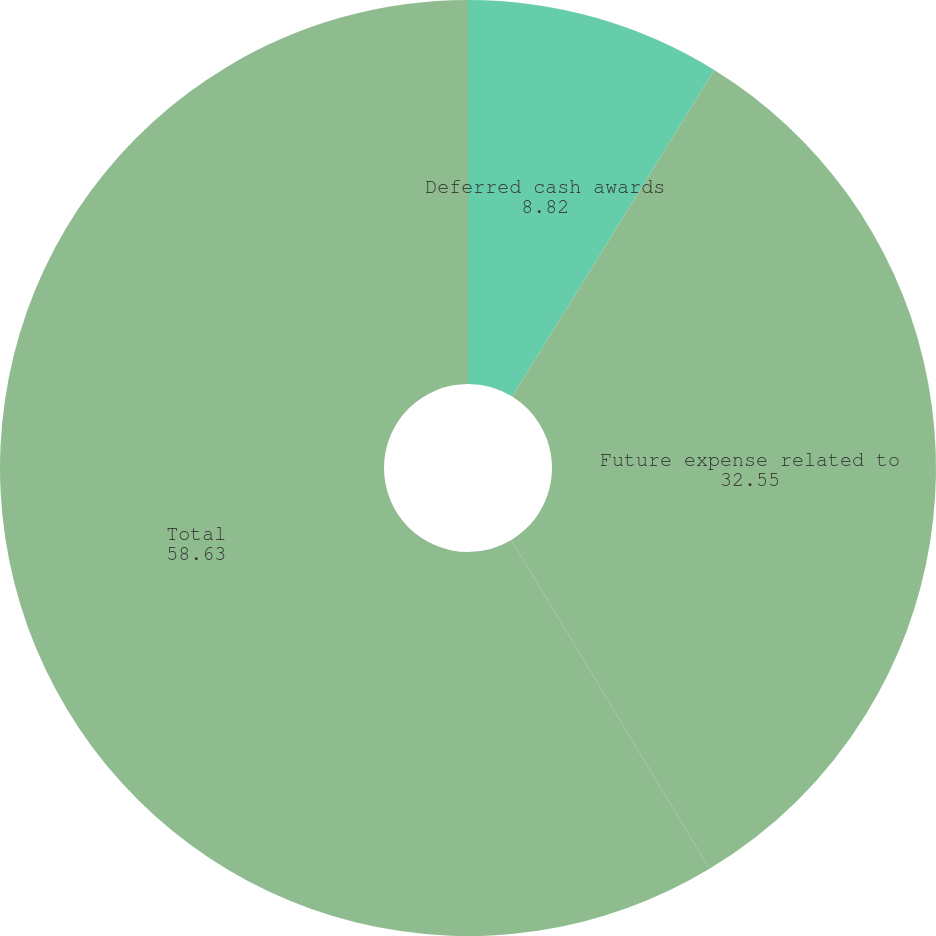Convert chart. <chart><loc_0><loc_0><loc_500><loc_500><pie_chart><fcel>Deferred cash awards<fcel>Future expense related to<fcel>Total<nl><fcel>8.82%<fcel>32.55%<fcel>58.63%<nl></chart> 